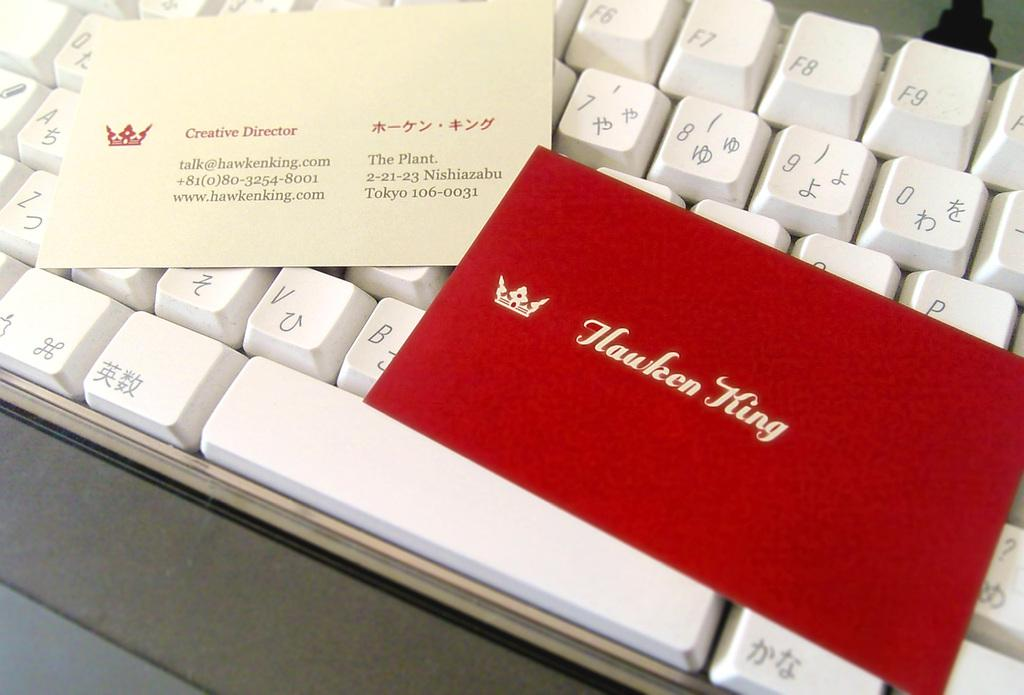<image>
Present a compact description of the photo's key features. A business card for the creative director sits on a keyboard. 